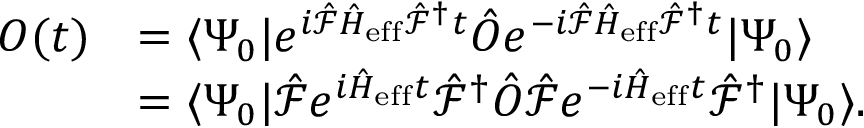<formula> <loc_0><loc_0><loc_500><loc_500>\begin{array} { r l } { O ( t ) } & { = \langle \Psi _ { 0 } | e ^ { i \hat { \mathcal { F } } \hat { H } _ { e f f } \hat { \mathcal { F } } ^ { \dagger } t } \hat { O } e ^ { - i \hat { \mathcal { F } } \hat { H } _ { e f f } \hat { \mathcal { F } } ^ { \dagger } t } | \Psi _ { 0 } \rangle } \\ & { = \langle \Psi _ { 0 } | \hat { \mathcal { F } } e ^ { i \hat { H } _ { e f f } t } \hat { \mathcal { F } } ^ { \dagger } \hat { O } \hat { \mathcal { F } } e ^ { - i \hat { H } _ { e f f } t } \hat { \mathcal { F } } ^ { \dagger } | \Psi _ { 0 } \rangle . } \end{array}</formula> 